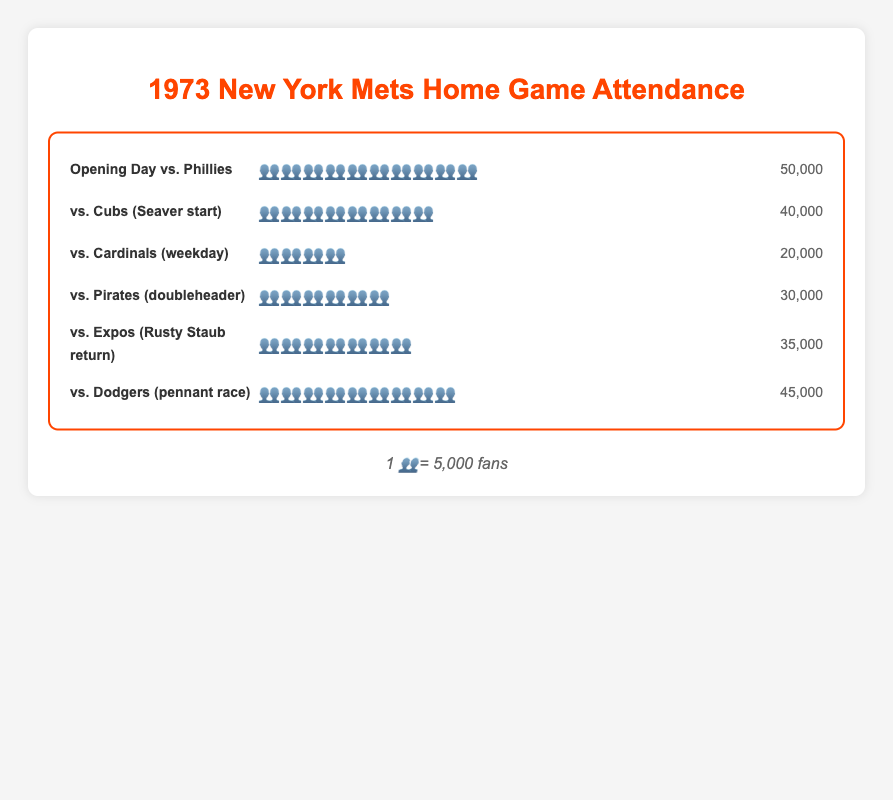What is the title of the chart? The chart's title is located at the top center and is distinctly larger and colored differently to stand out. It is "1973 New York Mets Home Game Attendance."
Answer: 1973 New York Mets Home Game Attendance How many fan emojis (👥) represent the attendance for "vs. Cubs (Seaver start)"? The chart row for "vs. Cubs (Seaver start)" shows exactly eight fan emojis (👥👥👥👥👥👥👥👥).
Answer: 8 What is the actual number of fans for the "vs. Dodgers (pennant race)" game? In the attendance row for this game, we see nine fan emojis and the actual number printed at the end, which is 45,000.
Answer: 45,000 Which game had the highest attendance? By comparing the number of fan emojis across all rows, "Opening Day vs. Phillies," with ten emojis, has the highest attendance.
Answer: Opening Day vs. Phillies What is the total attendance for the "Opening Day vs. Phillies" and "vs. Expos (Rusty Staub return)" games? First, convert the emojis to actual numbers: "Opening Day vs. Phillies" has 10 emojis (50,000 fans) and "vs. Expos" has 7 emojis (35,000 fans). Adding them, 50,000 + 35,000 = 85,000.
Answer: 85,000 What is the average attendance for the "vs. Cardinals (weekday)" and "vs. Pirates (doubleheader)" games? The "vs. Cardinals" game has 4 emojis (20,000 fans) and the "vs. Pirates" game has 6 emojis (30,000 fans). The sum is 20,000 + 30,000 = 50,000. The average attendance is 50,000 / 2 = 25,000.
Answer: 25,000 Which game had fewer fans: "vs. Expos (Rusty Staub return)" or "vs. Pirates (doubleheader)"? The "vs. Expos" game has 7 emojis (35,000 fans), and the "vs. Pirates" game has 6 emojis (30,000 fans). Comparatively, "vs. Pirates" had fewer fans.
Answer: vs. Pirates (doubleheader) How many more fans attended the "vs. Dodgers (pennant race)" game compared to the "vs. Cardinals (weekday)" game? The "vs. Dodgers" game has 9 emojis (45,000 fans) and the "vs. Cardinals" game has 4 emojis (20,000 fans). The difference is 45,000 - 20,000 = 25,000 more fans.
Answer: 25,000 What is the median attendance figure for the given games? List the actual attendance figures in ascending order: 20,000, 30,000, 35,000, 40,000, 45,000, 50,000. The median is the average of the middle two values: (35,000 + 40,000) / 2 = 37,500.
Answer: 37,500 Which games had an attendance of fewer than 30,000 fans? By examining the rows, "vs. Cardinals (weekday)" with 20,000 fans and "vs. Pirates (doubleheader)" with 30,000 fans meet this criterion. Note: "vs. Pirates" exactly 30,000 but is included in some metrics.
Answer: vs. Cardinals (weekday), vs. Pirates (doubleheader) 